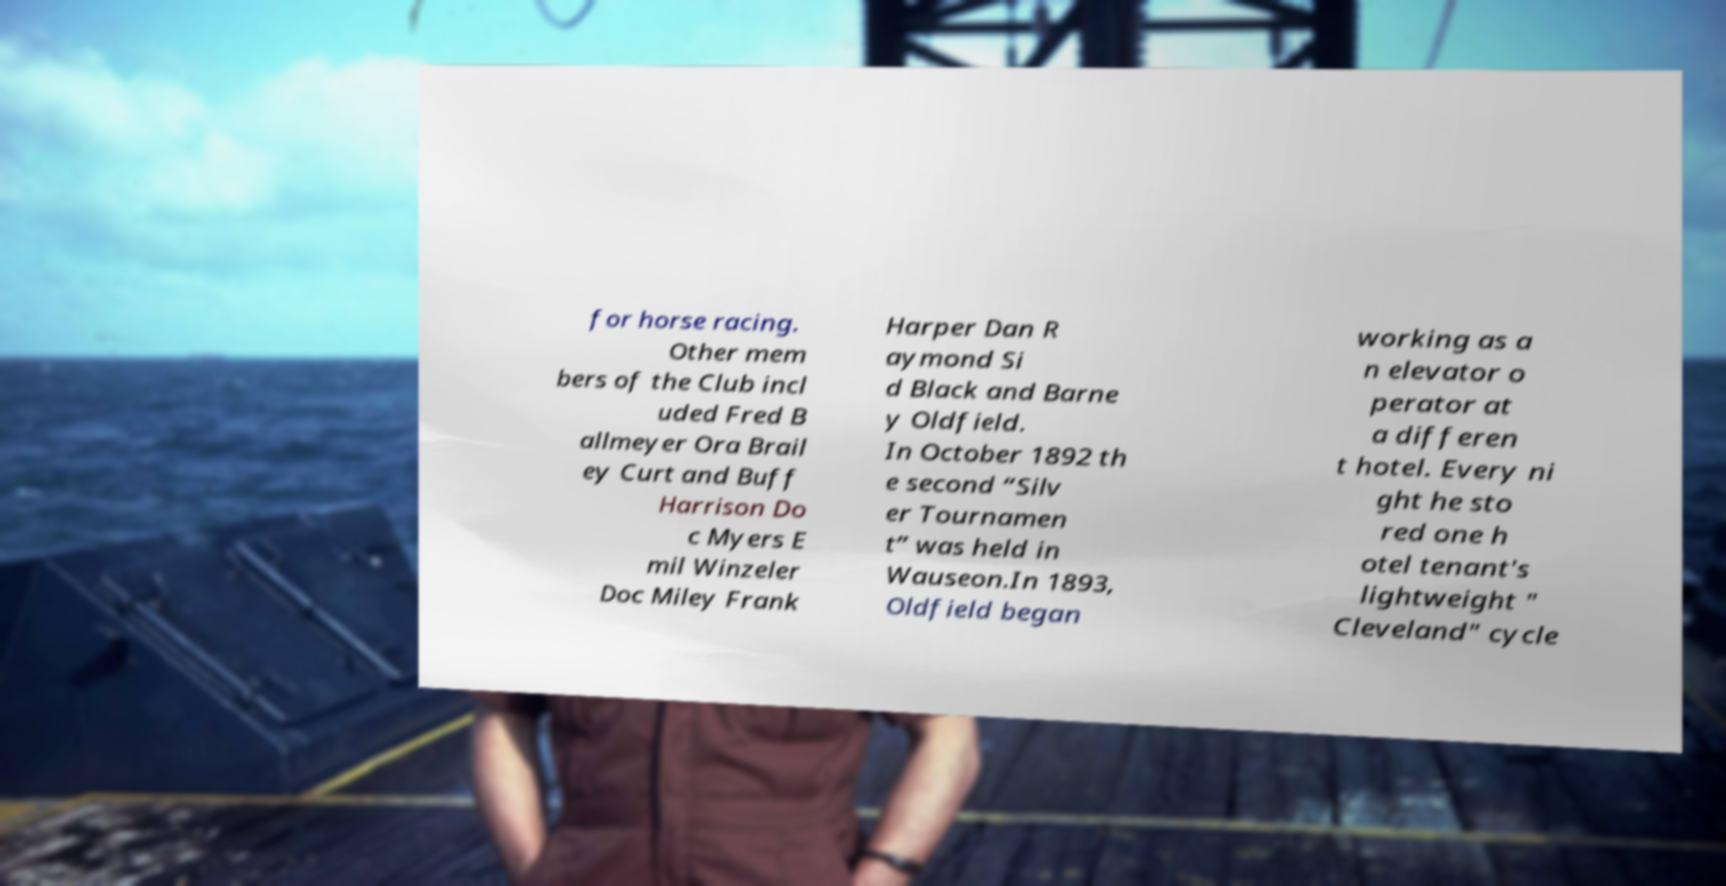Please read and relay the text visible in this image. What does it say? for horse racing. Other mem bers of the Club incl uded Fred B allmeyer Ora Brail ey Curt and Buff Harrison Do c Myers E mil Winzeler Doc Miley Frank Harper Dan R aymond Si d Black and Barne y Oldfield. In October 1892 th e second “Silv er Tournamen t” was held in Wauseon.In 1893, Oldfield began working as a n elevator o perator at a differen t hotel. Every ni ght he sto red one h otel tenant's lightweight " Cleveland" cycle 